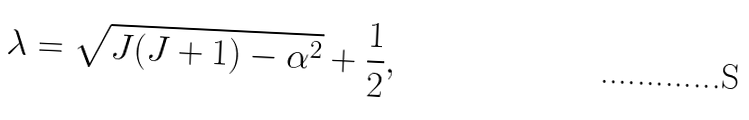<formula> <loc_0><loc_0><loc_500><loc_500>\lambda = \sqrt { J ( J + 1 ) - \alpha ^ { 2 } } + \frac { 1 } { 2 } ,</formula> 